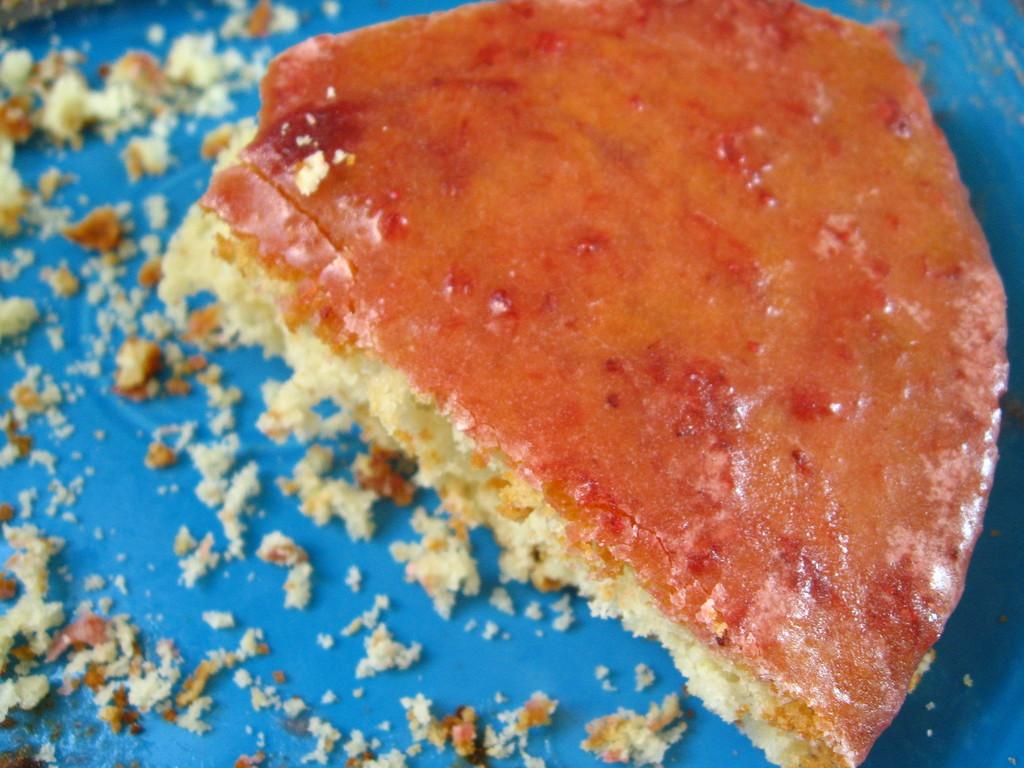What types of items can be seen in the image? There are food items in the image. What is the color of the object on which the food items are placed? The food items are on a blue object. Is there a judge present in the image? No, there is no judge present in the image. What type of field can be seen in the image? There is no field present in the image. 